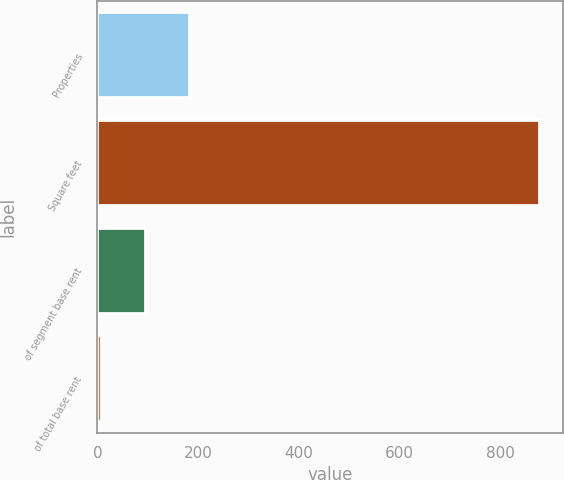<chart> <loc_0><loc_0><loc_500><loc_500><bar_chart><fcel>Properties<fcel>Square feet<fcel>of segment base rent<fcel>of total base rent<nl><fcel>183.2<fcel>880<fcel>96.1<fcel>9<nl></chart> 